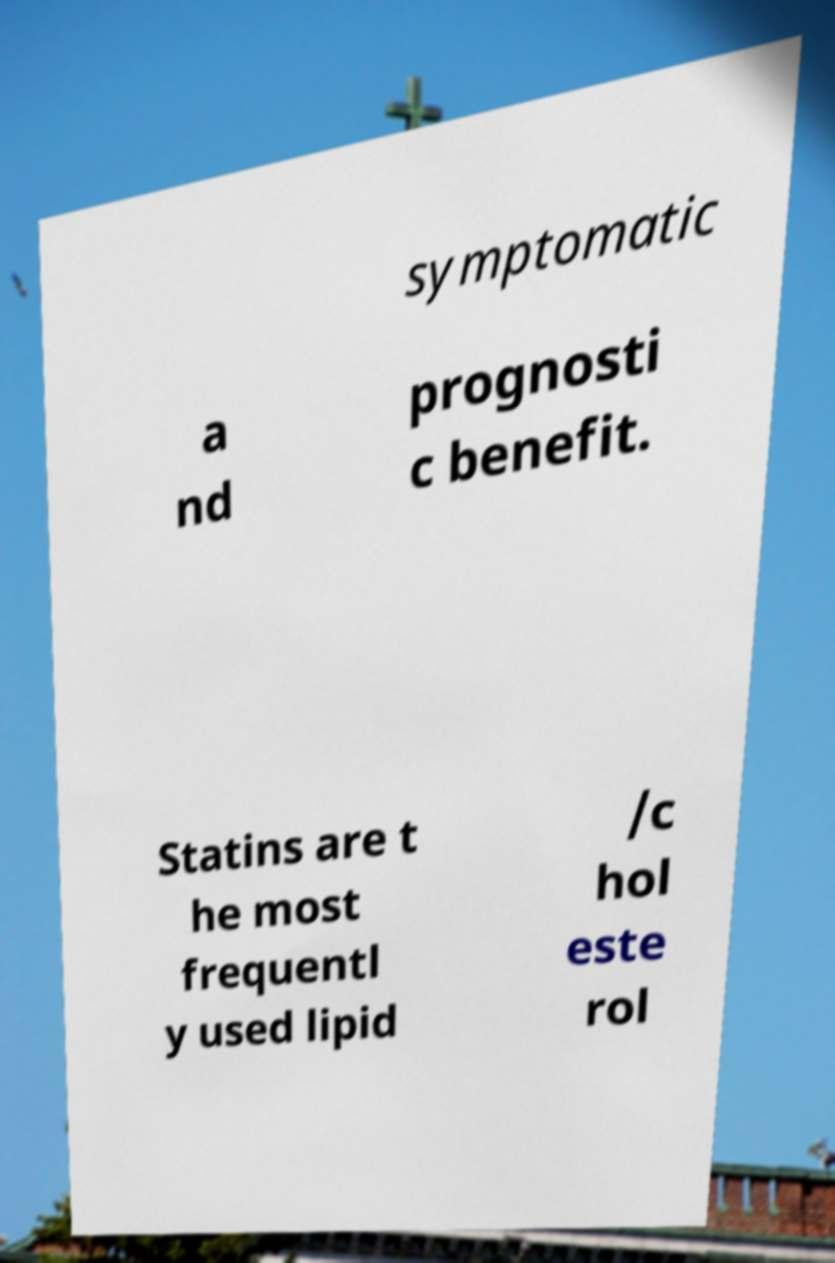I need the written content from this picture converted into text. Can you do that? symptomatic a nd prognosti c benefit. Statins are t he most frequentl y used lipid /c hol este rol 